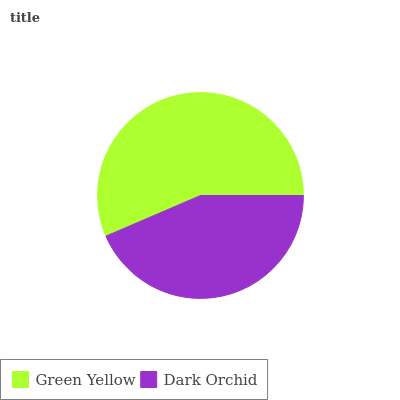Is Dark Orchid the minimum?
Answer yes or no. Yes. Is Green Yellow the maximum?
Answer yes or no. Yes. Is Dark Orchid the maximum?
Answer yes or no. No. Is Green Yellow greater than Dark Orchid?
Answer yes or no. Yes. Is Dark Orchid less than Green Yellow?
Answer yes or no. Yes. Is Dark Orchid greater than Green Yellow?
Answer yes or no. No. Is Green Yellow less than Dark Orchid?
Answer yes or no. No. Is Green Yellow the high median?
Answer yes or no. Yes. Is Dark Orchid the low median?
Answer yes or no. Yes. Is Dark Orchid the high median?
Answer yes or no. No. Is Green Yellow the low median?
Answer yes or no. No. 